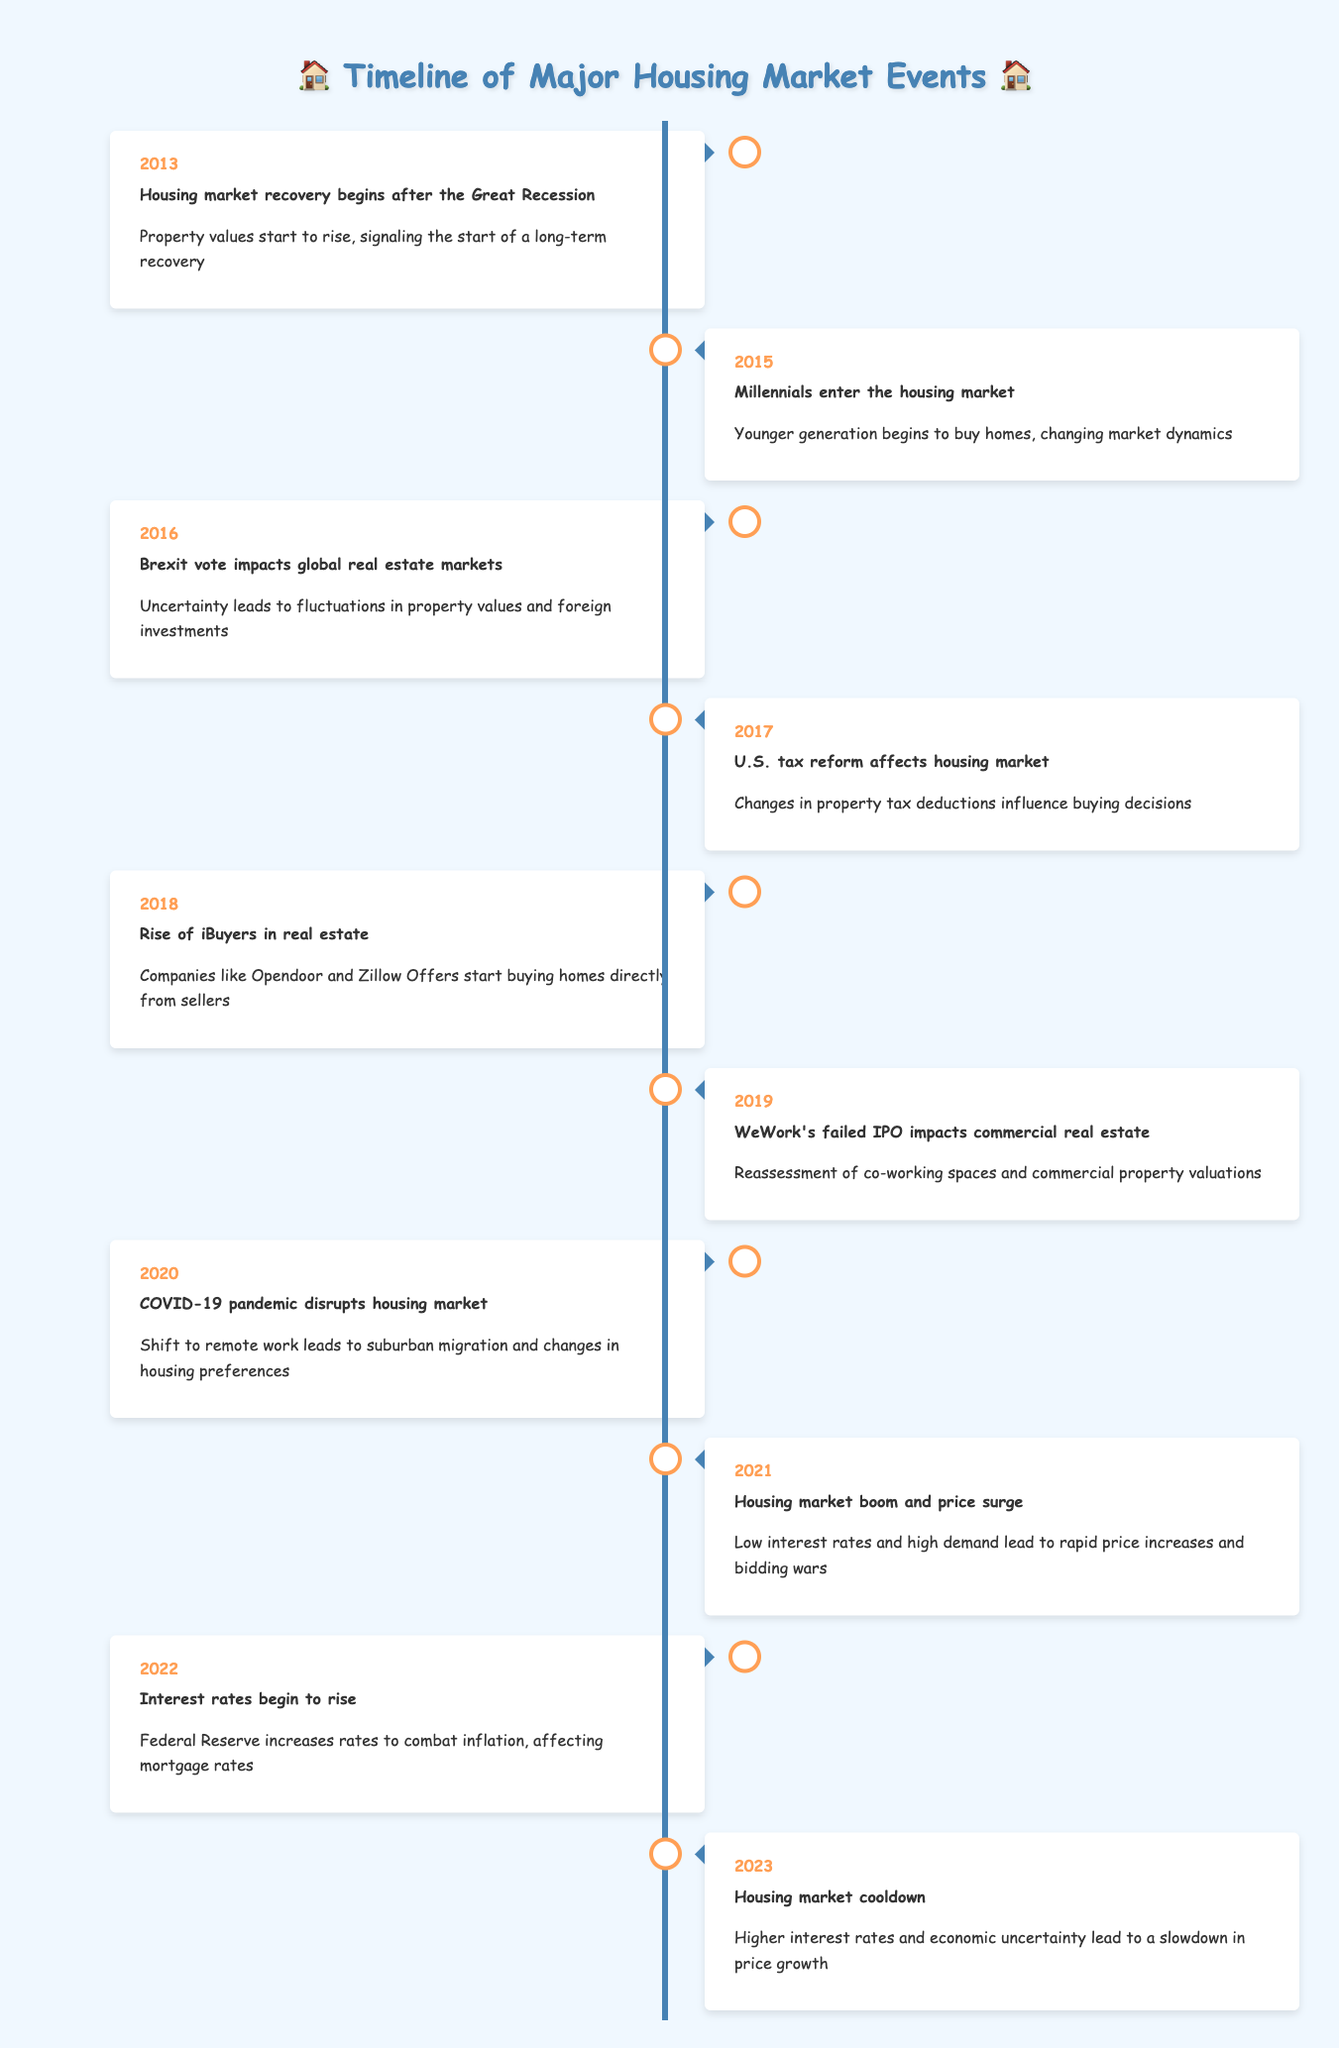What year did the housing market recovery begin? The table shows that the housing market recovery began in 2013, as indicated by the event listed for that year.
Answer: 2013 What event occurred in 2018? According to the table, the event in 2018 was the rise of iBuyers in real estate as companies like Opendoor and Zillow Offers started buying homes directly from sellers.
Answer: Rise of iBuyers in real estate Which year saw a significant impact from the COVID-19 pandemic? The table indicates that in 2020, the COVID-19 pandemic disrupted the housing market, leading to changes in housing preferences and suburban migration.
Answer: 2020 Did interest rates increase in 2022? The table confirms that interest rates began to rise in 2022, as stated in the event description for that year.
Answer: Yes In which years did significant changes in the housing market related to taxes occur? Analyzing the table, the years 2017 (U.S. tax reform affects the housing market) and 2022 (Interest rates begin to rise) are associated with significant changes related to taxes. Therefore, both 2017 and 2022 are relevant years.
Answer: 2017 and 2022 What was the trend in property values after the Great Recession? The table indicates that after the Great Recession, starting in 2013, property values began to rise, signaling a long-term recovery in the housing market.
Answer: Rising property values What was the impact of the Brexit vote on the housing market in 2016? The table shows that the Brexit vote in 2016 led to uncertainty, which caused fluctuations in property values and affected foreign investments in real estate.
Answer: Fluctuations in property values and foreign investments How many years were associated with a cooldown or decline in the housing market? The events of 2022 (interest rates begin to rise) and 2023 (housing market cooldown) indicate a trend towards a cooldown or decline in the housing market, thus accounting for two years.
Answer: 2 years What event marked the increase of iBuyers, and how might it have changed the market? The rise of iBuyers in 2018 marked the event where companies started directly purchasing homes, which likely changed the dynamics of the market by altering traditional selling processes.
Answer: Rise of iBuyers in 2018 